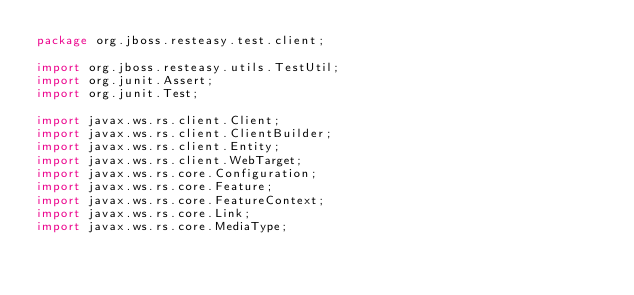Convert code to text. <code><loc_0><loc_0><loc_500><loc_500><_Java_>package org.jboss.resteasy.test.client;

import org.jboss.resteasy.utils.TestUtil;
import org.junit.Assert;
import org.junit.Test;

import javax.ws.rs.client.Client;
import javax.ws.rs.client.ClientBuilder;
import javax.ws.rs.client.Entity;
import javax.ws.rs.client.WebTarget;
import javax.ws.rs.core.Configuration;
import javax.ws.rs.core.Feature;
import javax.ws.rs.core.FeatureContext;
import javax.ws.rs.core.Link;
import javax.ws.rs.core.MediaType;</code> 